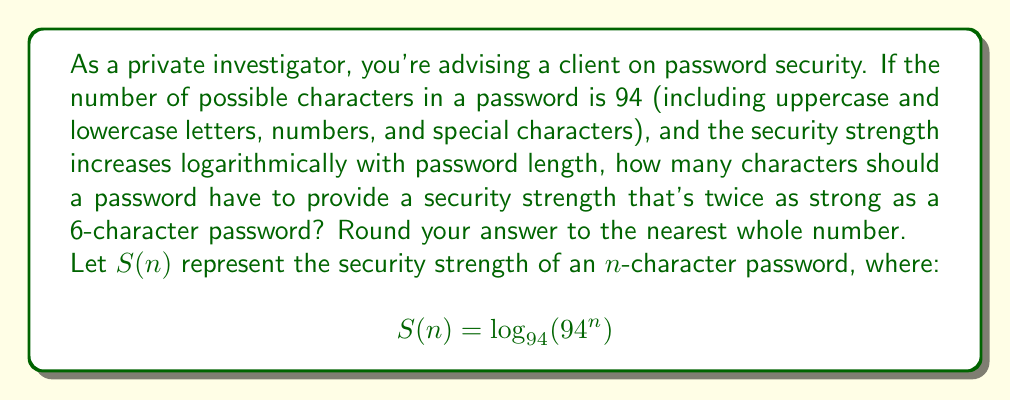What is the answer to this math problem? Let's approach this step-by-step:

1) First, we need to express the security strength of a 6-character password:
   $$S(6) = \log_{94}(94^6)$$

2) We want to find $n$ such that $S(n) = 2S(6)$. So we can set up the equation:
   $$\log_{94}(94^n) = 2\log_{94}(94^6)$$

3) Using the logarithm property $\log_a(x^n) = n\log_a(x)$, we can simplify:
   $$n = 2 \cdot 6 = 12$$

4) This means a 12-character password would be twice as strong as a 6-character password.

5) However, the question asks for the security strength to be twice as strong, not the password length to be twice as long. We need to solve:
   $$\log_{94}(94^n) = 2 \cdot 6$$

6) Using the inverse function (exponential):
   $$94^n = 94^{12}$$

7) Taking the logarithm of both sides (any base will do, let's use base 94):
   $$n = 12$$

8) Therefore, a password needs to be 12 characters long to be twice as strong as a 6-character password.

This demonstrates how password strength increases logarithmically with length, emphasizing the importance of using longer passwords to significantly increase security.
Answer: 12 characters 